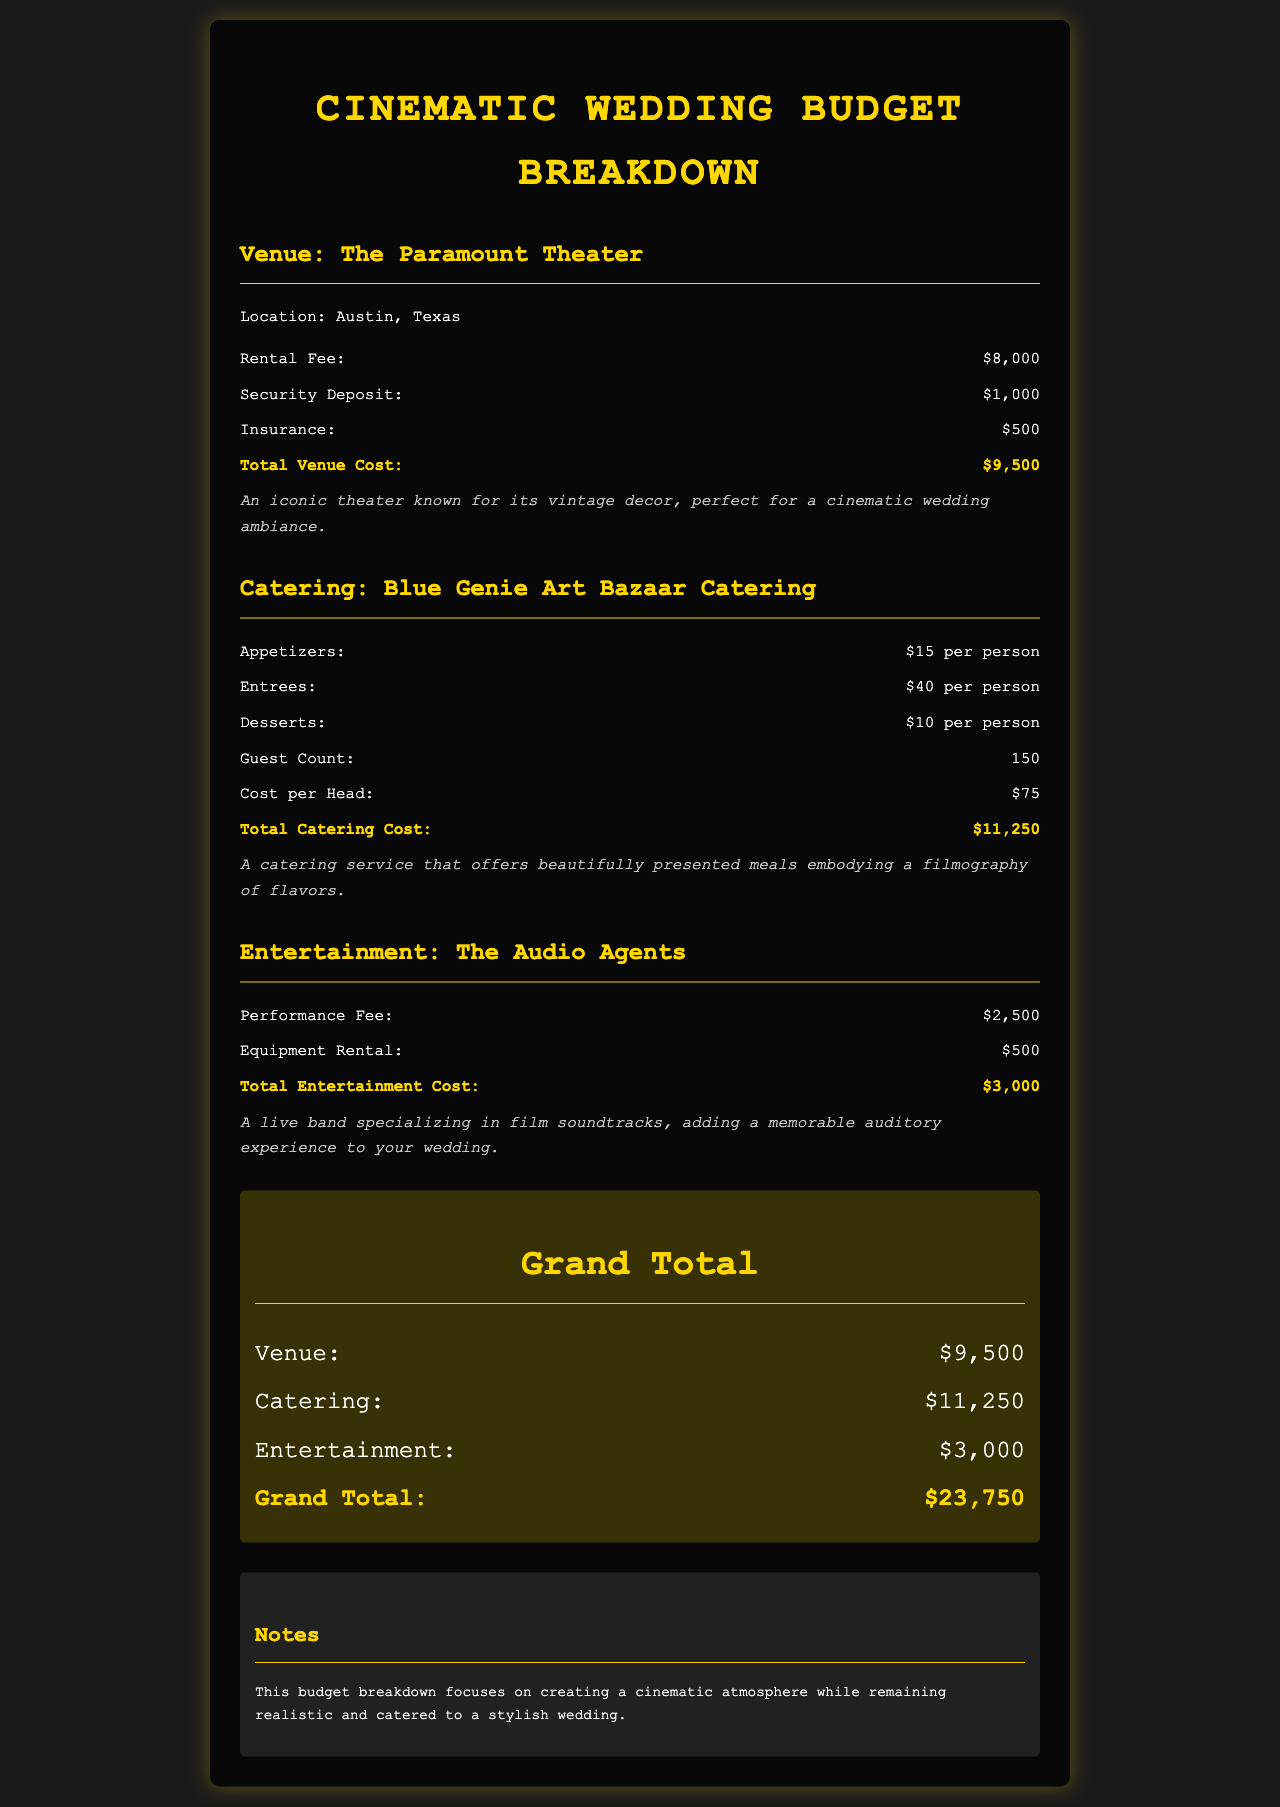What is the venue name? The venue is listed at the top of the venue section as The Paramount Theater.
Answer: The Paramount Theater What is the total catering cost? The total catering cost is explicitly mentioned in the catering section as $11,250.
Answer: $11,250 How much is the rental fee for the venue? The rental fee is specified in the document as $8,000.
Answer: $8,000 What is the guest count for the catering? The guest count is provided in the catering section as 150.
Answer: 150 What is the performance fee for entertainment? The performance fee is listed in the entertainment section as $2,500.
Answer: $2,500 What is the address location of the venue? The address location is given as Austin, Texas in the venue section.
Answer: Austin, Texas What is the grand total for the wedding budget? The grand total is mentioned at the end of the document as $23,750.
Answer: $23,750 What type of cuisine does the catering service emphasize? The catering service is described as offering beautifully presented meals embodying a filmography of flavors.
Answer: Filmography of flavors How much is the security deposit for the venue? The security deposit is explicitly stated in the document as $1,000.
Answer: $1,000 